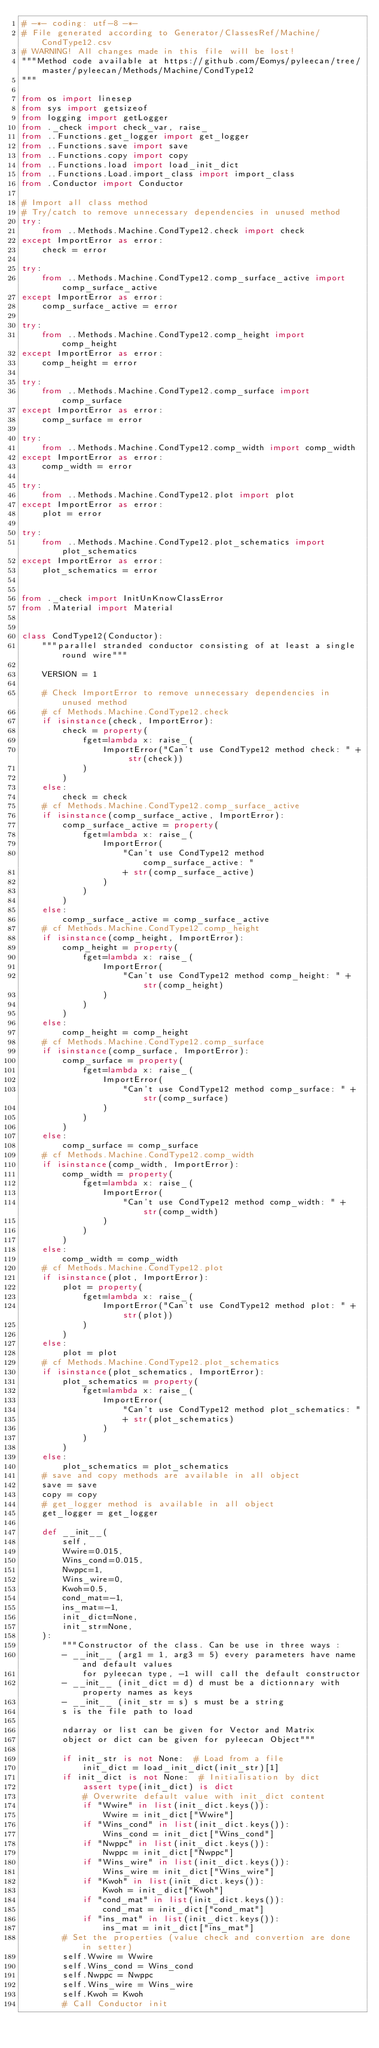Convert code to text. <code><loc_0><loc_0><loc_500><loc_500><_Python_># -*- coding: utf-8 -*-
# File generated according to Generator/ClassesRef/Machine/CondType12.csv
# WARNING! All changes made in this file will be lost!
"""Method code available at https://github.com/Eomys/pyleecan/tree/master/pyleecan/Methods/Machine/CondType12
"""

from os import linesep
from sys import getsizeof
from logging import getLogger
from ._check import check_var, raise_
from ..Functions.get_logger import get_logger
from ..Functions.save import save
from ..Functions.copy import copy
from ..Functions.load import load_init_dict
from ..Functions.Load.import_class import import_class
from .Conductor import Conductor

# Import all class method
# Try/catch to remove unnecessary dependencies in unused method
try:
    from ..Methods.Machine.CondType12.check import check
except ImportError as error:
    check = error

try:
    from ..Methods.Machine.CondType12.comp_surface_active import comp_surface_active
except ImportError as error:
    comp_surface_active = error

try:
    from ..Methods.Machine.CondType12.comp_height import comp_height
except ImportError as error:
    comp_height = error

try:
    from ..Methods.Machine.CondType12.comp_surface import comp_surface
except ImportError as error:
    comp_surface = error

try:
    from ..Methods.Machine.CondType12.comp_width import comp_width
except ImportError as error:
    comp_width = error

try:
    from ..Methods.Machine.CondType12.plot import plot
except ImportError as error:
    plot = error

try:
    from ..Methods.Machine.CondType12.plot_schematics import plot_schematics
except ImportError as error:
    plot_schematics = error


from ._check import InitUnKnowClassError
from .Material import Material


class CondType12(Conductor):
    """parallel stranded conductor consisting of at least a single round wire"""

    VERSION = 1

    # Check ImportError to remove unnecessary dependencies in unused method
    # cf Methods.Machine.CondType12.check
    if isinstance(check, ImportError):
        check = property(
            fget=lambda x: raise_(
                ImportError("Can't use CondType12 method check: " + str(check))
            )
        )
    else:
        check = check
    # cf Methods.Machine.CondType12.comp_surface_active
    if isinstance(comp_surface_active, ImportError):
        comp_surface_active = property(
            fget=lambda x: raise_(
                ImportError(
                    "Can't use CondType12 method comp_surface_active: "
                    + str(comp_surface_active)
                )
            )
        )
    else:
        comp_surface_active = comp_surface_active
    # cf Methods.Machine.CondType12.comp_height
    if isinstance(comp_height, ImportError):
        comp_height = property(
            fget=lambda x: raise_(
                ImportError(
                    "Can't use CondType12 method comp_height: " + str(comp_height)
                )
            )
        )
    else:
        comp_height = comp_height
    # cf Methods.Machine.CondType12.comp_surface
    if isinstance(comp_surface, ImportError):
        comp_surface = property(
            fget=lambda x: raise_(
                ImportError(
                    "Can't use CondType12 method comp_surface: " + str(comp_surface)
                )
            )
        )
    else:
        comp_surface = comp_surface
    # cf Methods.Machine.CondType12.comp_width
    if isinstance(comp_width, ImportError):
        comp_width = property(
            fget=lambda x: raise_(
                ImportError(
                    "Can't use CondType12 method comp_width: " + str(comp_width)
                )
            )
        )
    else:
        comp_width = comp_width
    # cf Methods.Machine.CondType12.plot
    if isinstance(plot, ImportError):
        plot = property(
            fget=lambda x: raise_(
                ImportError("Can't use CondType12 method plot: " + str(plot))
            )
        )
    else:
        plot = plot
    # cf Methods.Machine.CondType12.plot_schematics
    if isinstance(plot_schematics, ImportError):
        plot_schematics = property(
            fget=lambda x: raise_(
                ImportError(
                    "Can't use CondType12 method plot_schematics: "
                    + str(plot_schematics)
                )
            )
        )
    else:
        plot_schematics = plot_schematics
    # save and copy methods are available in all object
    save = save
    copy = copy
    # get_logger method is available in all object
    get_logger = get_logger

    def __init__(
        self,
        Wwire=0.015,
        Wins_cond=0.015,
        Nwppc=1,
        Wins_wire=0,
        Kwoh=0.5,
        cond_mat=-1,
        ins_mat=-1,
        init_dict=None,
        init_str=None,
    ):
        """Constructor of the class. Can be use in three ways :
        - __init__ (arg1 = 1, arg3 = 5) every parameters have name and default values
            for pyleecan type, -1 will call the default constructor
        - __init__ (init_dict = d) d must be a dictionnary with property names as keys
        - __init__ (init_str = s) s must be a string
        s is the file path to load

        ndarray or list can be given for Vector and Matrix
        object or dict can be given for pyleecan Object"""

        if init_str is not None:  # Load from a file
            init_dict = load_init_dict(init_str)[1]
        if init_dict is not None:  # Initialisation by dict
            assert type(init_dict) is dict
            # Overwrite default value with init_dict content
            if "Wwire" in list(init_dict.keys()):
                Wwire = init_dict["Wwire"]
            if "Wins_cond" in list(init_dict.keys()):
                Wins_cond = init_dict["Wins_cond"]
            if "Nwppc" in list(init_dict.keys()):
                Nwppc = init_dict["Nwppc"]
            if "Wins_wire" in list(init_dict.keys()):
                Wins_wire = init_dict["Wins_wire"]
            if "Kwoh" in list(init_dict.keys()):
                Kwoh = init_dict["Kwoh"]
            if "cond_mat" in list(init_dict.keys()):
                cond_mat = init_dict["cond_mat"]
            if "ins_mat" in list(init_dict.keys()):
                ins_mat = init_dict["ins_mat"]
        # Set the properties (value check and convertion are done in setter)
        self.Wwire = Wwire
        self.Wins_cond = Wins_cond
        self.Nwppc = Nwppc
        self.Wins_wire = Wins_wire
        self.Kwoh = Kwoh
        # Call Conductor init</code> 